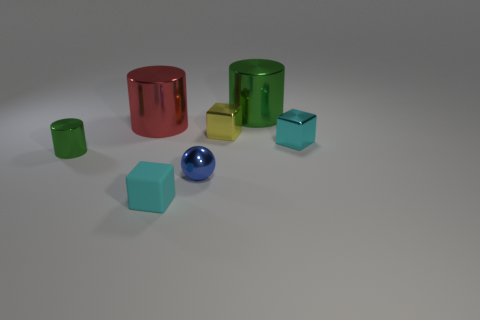Subtract all tiny green shiny cylinders. How many cylinders are left? 2 Subtract 1 blocks. How many blocks are left? 2 Subtract all cyan blocks. How many blocks are left? 1 Add 2 small metallic things. How many objects exist? 9 Subtract all gray balls. Subtract all blue cubes. How many balls are left? 1 Subtract all red balls. How many yellow blocks are left? 1 Subtract all cyan objects. Subtract all blue metal things. How many objects are left? 4 Add 1 yellow metal blocks. How many yellow metal blocks are left? 2 Add 5 large red metal cylinders. How many large red metal cylinders exist? 6 Subtract 0 gray cylinders. How many objects are left? 7 